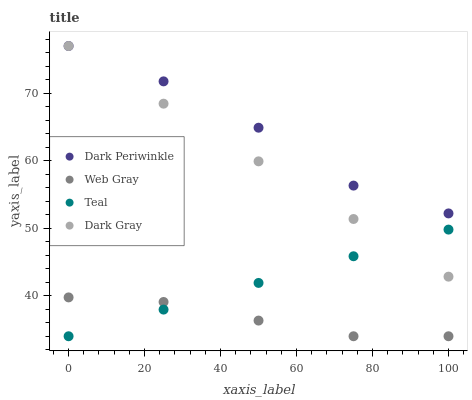Does Web Gray have the minimum area under the curve?
Answer yes or no. Yes. Does Dark Periwinkle have the maximum area under the curve?
Answer yes or no. Yes. Does Dark Periwinkle have the minimum area under the curve?
Answer yes or no. No. Does Web Gray have the maximum area under the curve?
Answer yes or no. No. Is Dark Gray the smoothest?
Answer yes or no. Yes. Is Dark Periwinkle the roughest?
Answer yes or no. Yes. Is Web Gray the smoothest?
Answer yes or no. No. Is Web Gray the roughest?
Answer yes or no. No. Does Web Gray have the lowest value?
Answer yes or no. Yes. Does Dark Periwinkle have the lowest value?
Answer yes or no. No. Does Dark Periwinkle have the highest value?
Answer yes or no. Yes. Does Web Gray have the highest value?
Answer yes or no. No. Is Teal less than Dark Periwinkle?
Answer yes or no. Yes. Is Dark Periwinkle greater than Teal?
Answer yes or no. Yes. Does Dark Periwinkle intersect Dark Gray?
Answer yes or no. Yes. Is Dark Periwinkle less than Dark Gray?
Answer yes or no. No. Is Dark Periwinkle greater than Dark Gray?
Answer yes or no. No. Does Teal intersect Dark Periwinkle?
Answer yes or no. No. 